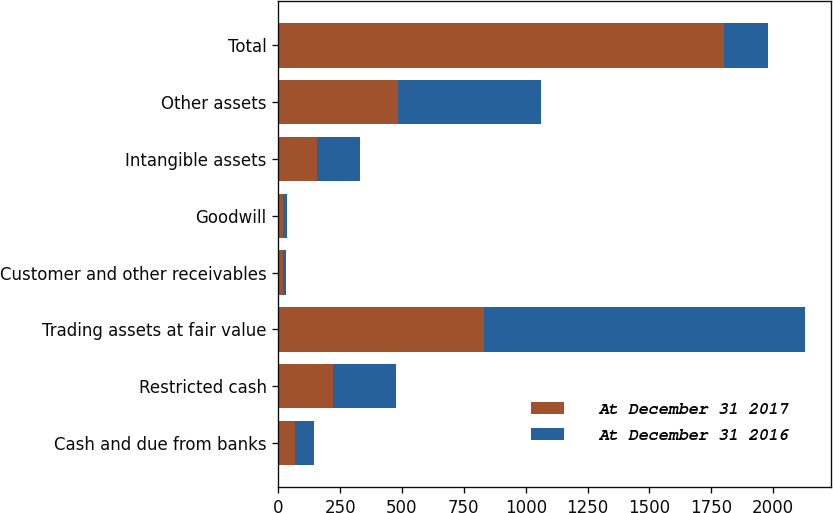Convert chart to OTSL. <chart><loc_0><loc_0><loc_500><loc_500><stacked_bar_chart><ecel><fcel>Cash and due from banks<fcel>Restricted cash<fcel>Trading assets at fair value<fcel>Customer and other receivables<fcel>Goodwill<fcel>Intangible assets<fcel>Other assets<fcel>Total<nl><fcel>At December 31 2017<fcel>69<fcel>222<fcel>833<fcel>19<fcel>18<fcel>155<fcel>485<fcel>1801<nl><fcel>At December 31 2016<fcel>74<fcel>255<fcel>1295<fcel>13<fcel>18<fcel>177<fcel>578<fcel>177<nl></chart> 